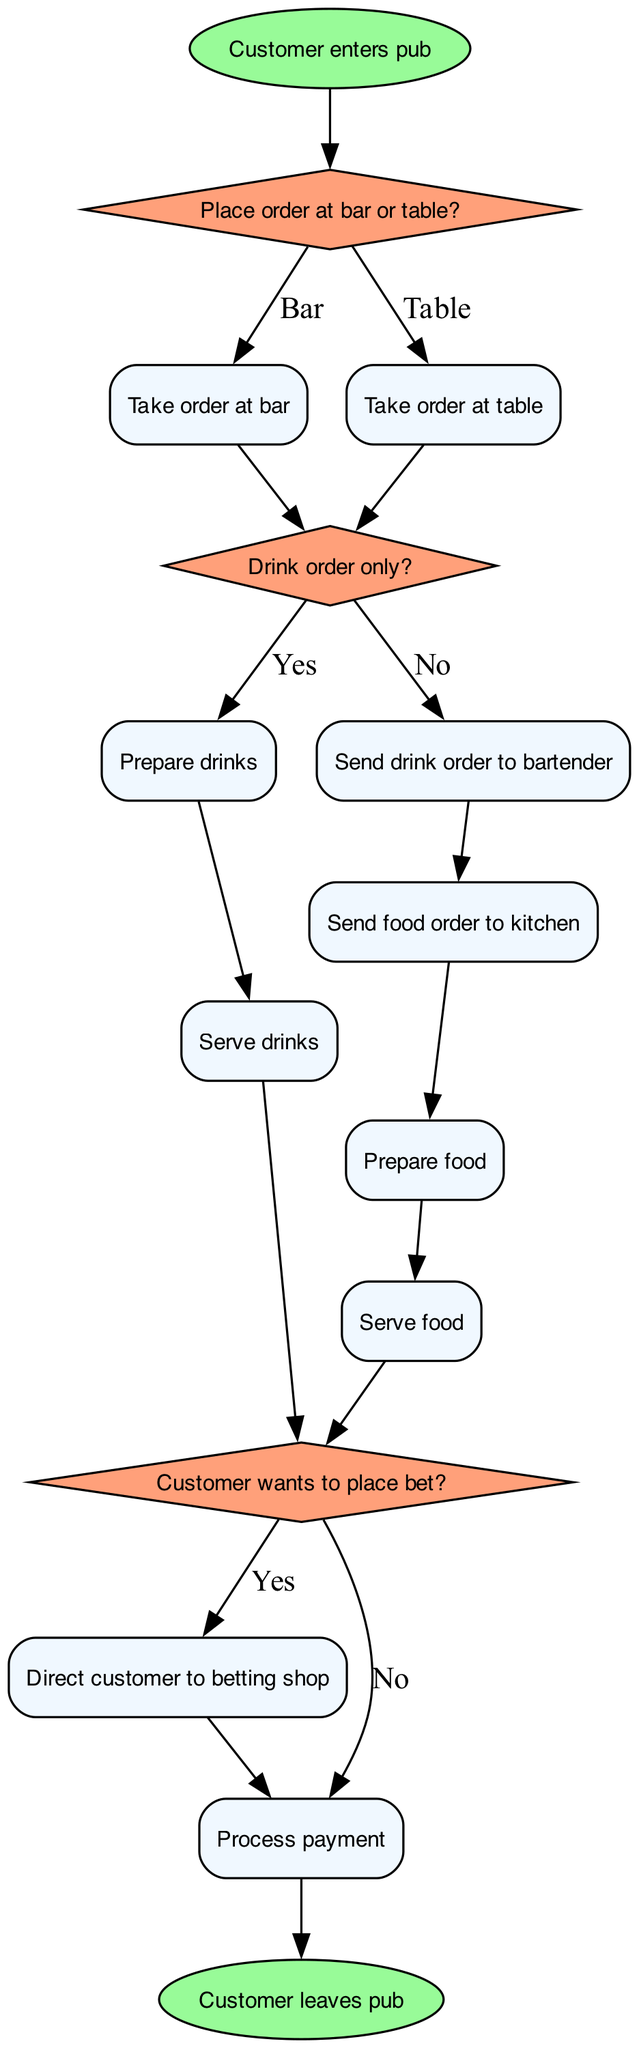What is the starting point of the process? The starting point of the process is indicated by the 'start' node, which states "Customer enters pub."
Answer: Customer enters pub How many decision nodes are in the diagram? The diagram contains three decision nodes: one about where to place the order, one about the drink order, and one about placing a bet.
Answer: Three What follows after a customer places their order at the bar? After placing an order at the bar, the next step is to check if it's a drink order only, indicated by 'decision2.'
Answer: Check drink order What happens if the customer wants to serve food? If the customer orders food, the flow goes from 'process5' (sending the food order to the kitchen) to 'process6' (preparing food) and then to 'process8' (serving food).
Answer: Serve food If a customer orders drinks, what is the next step in the process? After the drink order is prepared, the next step is 'process7,' where the drinks are served to the customer.
Answer: Serve drinks What is the final action in the flowchart? The flowchart culminates in the 'end' node, stating "Customer leaves pub," which signifies the completion of the process.
Answer: Customer leaves pub If the customer does not want to place a bet, where do they go next? If the customer does not want to place a bet, the flow proceeds directly to 'process10,' which is processing payment.
Answer: Process payment How does the flowchart indicate an order at the table? An order at the table is indicated by the edge leading from 'decision1' to 'process2,' labeled 'Table.'
Answer: Table What decision is made after drinks are served? After drinks are served, the next decision is whether the customer wants to place a bet, referred to as 'decision3.'
Answer: Place bet decision 